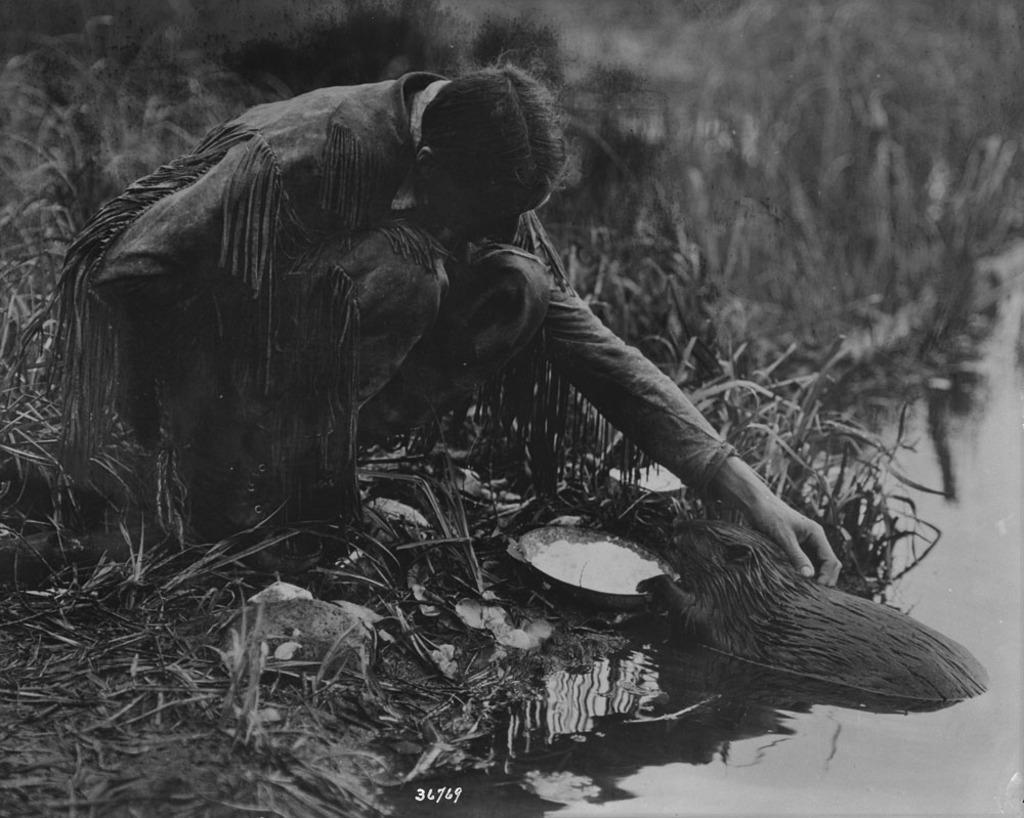Please provide a concise description of this image. This is a black and white image where we can see this person wearing dress and long boots is in the squat position. Here we can see an animal in the water and we can see the grass. 